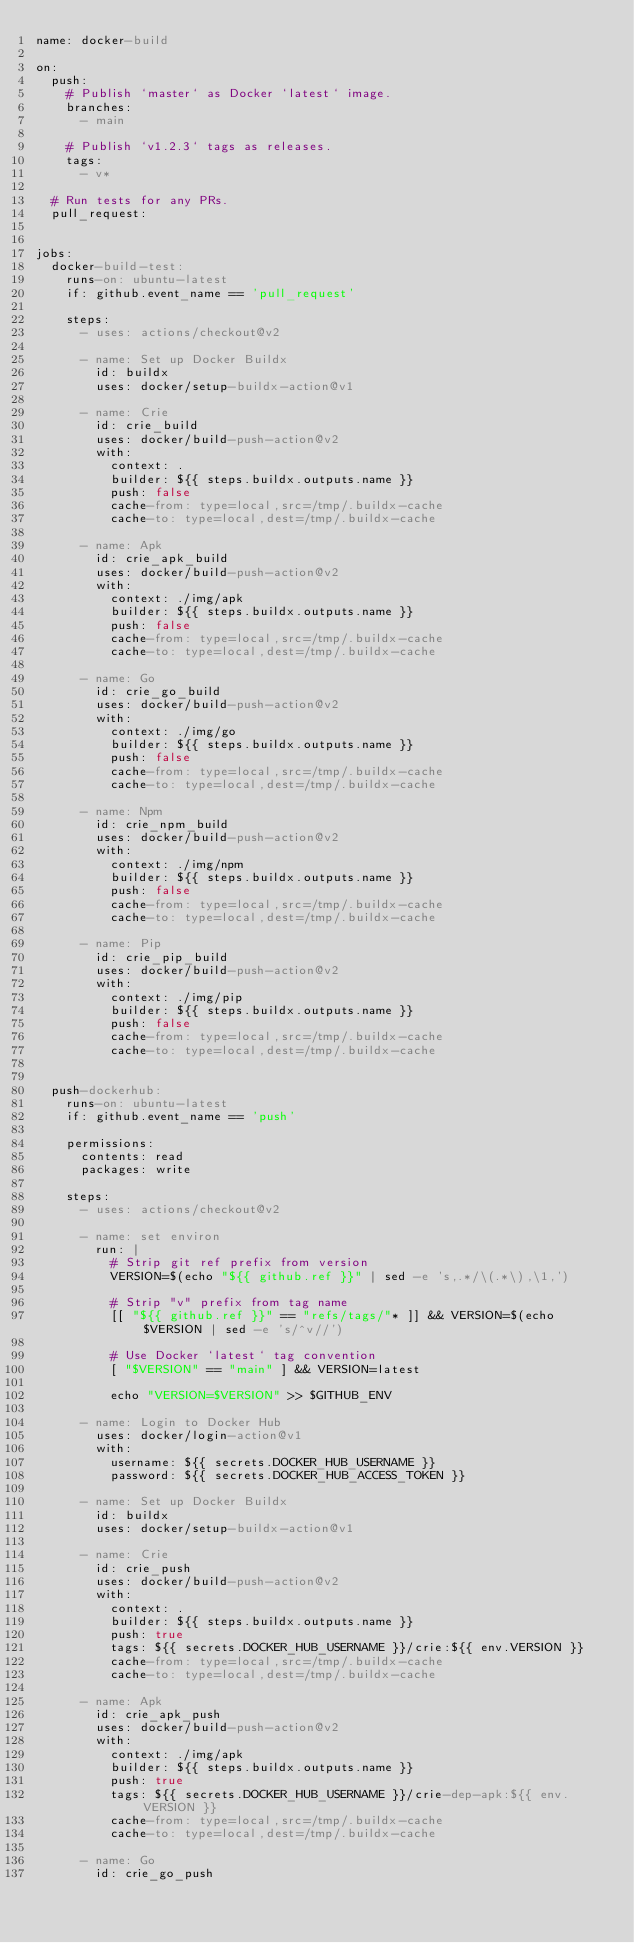Convert code to text. <code><loc_0><loc_0><loc_500><loc_500><_YAML_>name: docker-build

on:
  push:
    # Publish `master` as Docker `latest` image.
    branches:
      - main

    # Publish `v1.2.3` tags as releases.
    tags:
      - v*

  # Run tests for any PRs.
  pull_request:


jobs:
  docker-build-test:
    runs-on: ubuntu-latest
    if: github.event_name == 'pull_request'

    steps:
      - uses: actions/checkout@v2

      - name: Set up Docker Buildx
        id: buildx
        uses: docker/setup-buildx-action@v1

      - name: Crie
        id: crie_build
        uses: docker/build-push-action@v2
        with:
          context: .
          builder: ${{ steps.buildx.outputs.name }}
          push: false
          cache-from: type=local,src=/tmp/.buildx-cache
          cache-to: type=local,dest=/tmp/.buildx-cache

      - name: Apk
        id: crie_apk_build
        uses: docker/build-push-action@v2
        with:
          context: ./img/apk
          builder: ${{ steps.buildx.outputs.name }}
          push: false
          cache-from: type=local,src=/tmp/.buildx-cache
          cache-to: type=local,dest=/tmp/.buildx-cache

      - name: Go
        id: crie_go_build
        uses: docker/build-push-action@v2
        with:
          context: ./img/go
          builder: ${{ steps.buildx.outputs.name }}
          push: false
          cache-from: type=local,src=/tmp/.buildx-cache
          cache-to: type=local,dest=/tmp/.buildx-cache

      - name: Npm
        id: crie_npm_build
        uses: docker/build-push-action@v2
        with:
          context: ./img/npm
          builder: ${{ steps.buildx.outputs.name }}
          push: false
          cache-from: type=local,src=/tmp/.buildx-cache
          cache-to: type=local,dest=/tmp/.buildx-cache

      - name: Pip
        id: crie_pip_build
        uses: docker/build-push-action@v2
        with:
          context: ./img/pip
          builder: ${{ steps.buildx.outputs.name }}
          push: false
          cache-from: type=local,src=/tmp/.buildx-cache
          cache-to: type=local,dest=/tmp/.buildx-cache


  push-dockerhub:
    runs-on: ubuntu-latest
    if: github.event_name == 'push'

    permissions:
      contents: read
      packages: write

    steps:
      - uses: actions/checkout@v2

      - name: set environ
        run: |
          # Strip git ref prefix from version
          VERSION=$(echo "${{ github.ref }}" | sed -e 's,.*/\(.*\),\1,')

          # Strip "v" prefix from tag name
          [[ "${{ github.ref }}" == "refs/tags/"* ]] && VERSION=$(echo $VERSION | sed -e 's/^v//')

          # Use Docker `latest` tag convention
          [ "$VERSION" == "main" ] && VERSION=latest

          echo "VERSION=$VERSION" >> $GITHUB_ENV

      - name: Login to Docker Hub
        uses: docker/login-action@v1
        with:
          username: ${{ secrets.DOCKER_HUB_USERNAME }}
          password: ${{ secrets.DOCKER_HUB_ACCESS_TOKEN }}

      - name: Set up Docker Buildx
        id: buildx
        uses: docker/setup-buildx-action@v1

      - name: Crie
        id: crie_push
        uses: docker/build-push-action@v2
        with:
          context: .
          builder: ${{ steps.buildx.outputs.name }}
          push: true
          tags: ${{ secrets.DOCKER_HUB_USERNAME }}/crie:${{ env.VERSION }}
          cache-from: type=local,src=/tmp/.buildx-cache
          cache-to: type=local,dest=/tmp/.buildx-cache

      - name: Apk
        id: crie_apk_push
        uses: docker/build-push-action@v2
        with:
          context: ./img/apk
          builder: ${{ steps.buildx.outputs.name }}
          push: true
          tags: ${{ secrets.DOCKER_HUB_USERNAME }}/crie-dep-apk:${{ env.VERSION }}
          cache-from: type=local,src=/tmp/.buildx-cache
          cache-to: type=local,dest=/tmp/.buildx-cache

      - name: Go
        id: crie_go_push</code> 